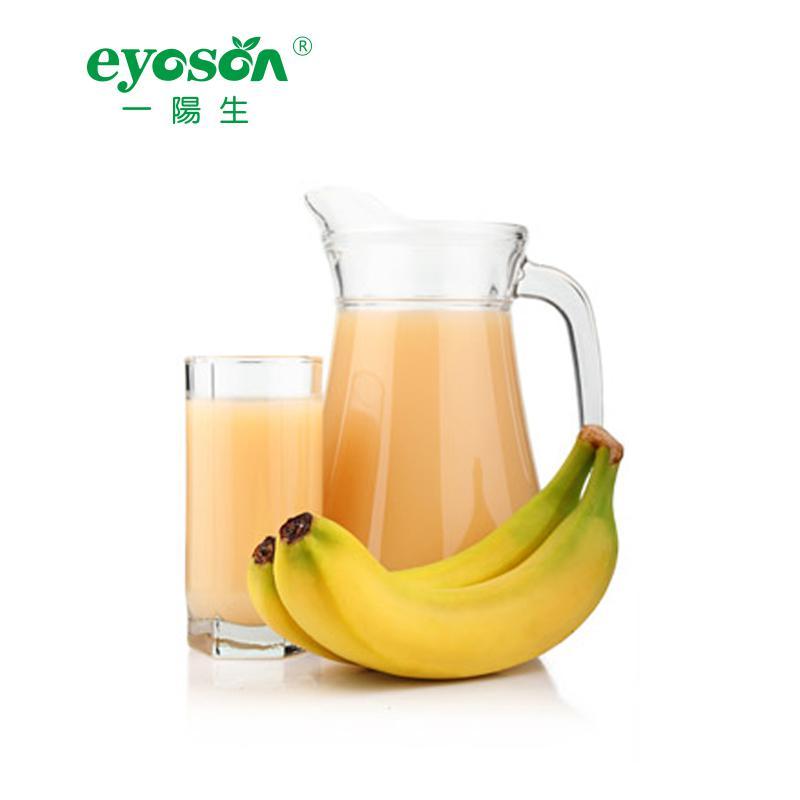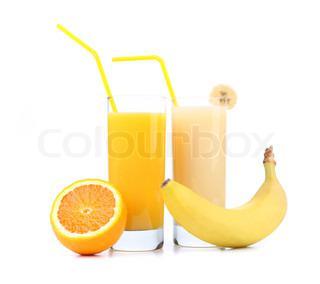The first image is the image on the left, the second image is the image on the right. Assess this claim about the two images: "The right image contains no more than one orange and one banana next to two smoothies.". Correct or not? Answer yes or no. Yes. The first image is the image on the left, the second image is the image on the right. For the images shown, is this caption "A pitcher and a glass of the same beverage are behind a small bunch of bananas." true? Answer yes or no. Yes. 